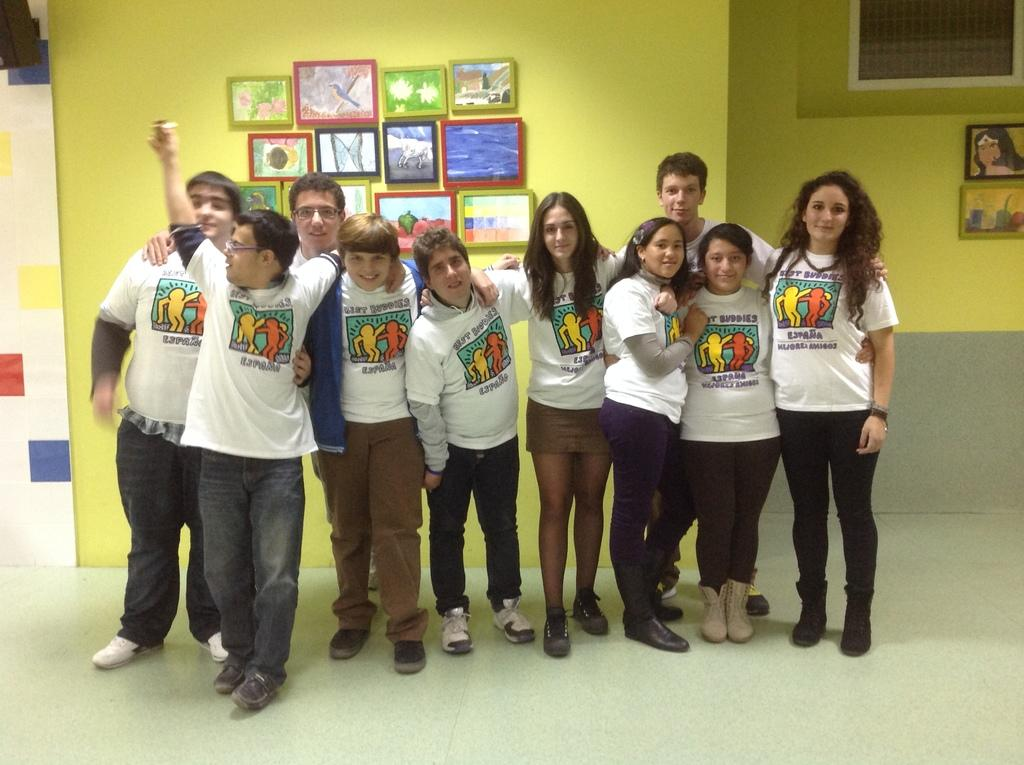How many people are in the image? There is a group of persons in the image. What are the people in the image doing? The persons are standing and smiling. What can be seen on the wall in the background? There are frames on the wall in the background. What color is the wall in the image? The wall is yellow in color. What type of corn is being used to paste on the bottle in the image? There is no corn, paste, or bottle present in the image. 